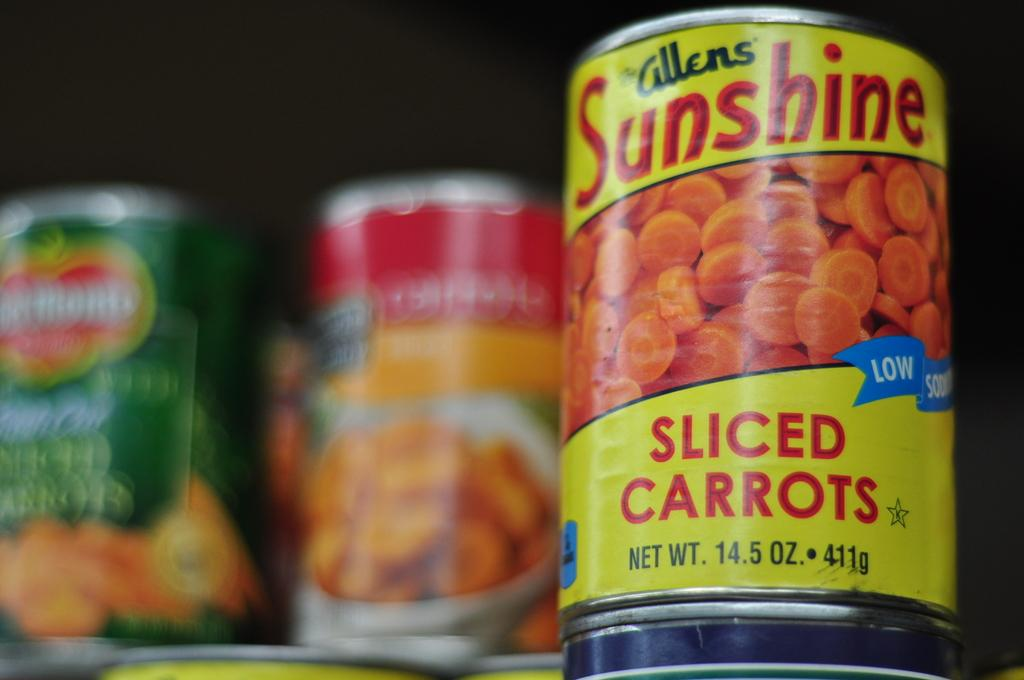What objects are present in the image? There are tins in the image. What is written or printed on the tins? The tins have alphabets and numbers on them. Can you describe the background of the image? The background of the image is blurred. Is the cake in the image being served quietly? There is no cake present in the image, so it cannot be served or have any associated volume level. 